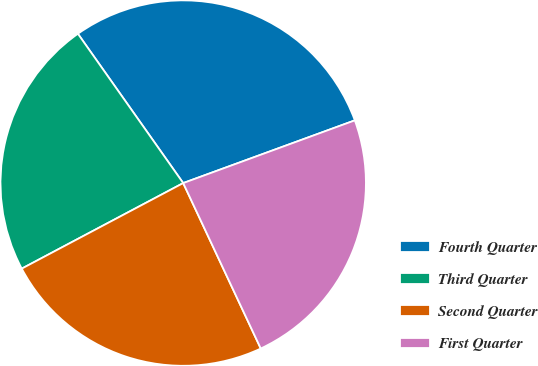Convert chart to OTSL. <chart><loc_0><loc_0><loc_500><loc_500><pie_chart><fcel>Fourth Quarter<fcel>Third Quarter<fcel>Second Quarter<fcel>First Quarter<nl><fcel>29.2%<fcel>22.98%<fcel>24.22%<fcel>23.6%<nl></chart> 